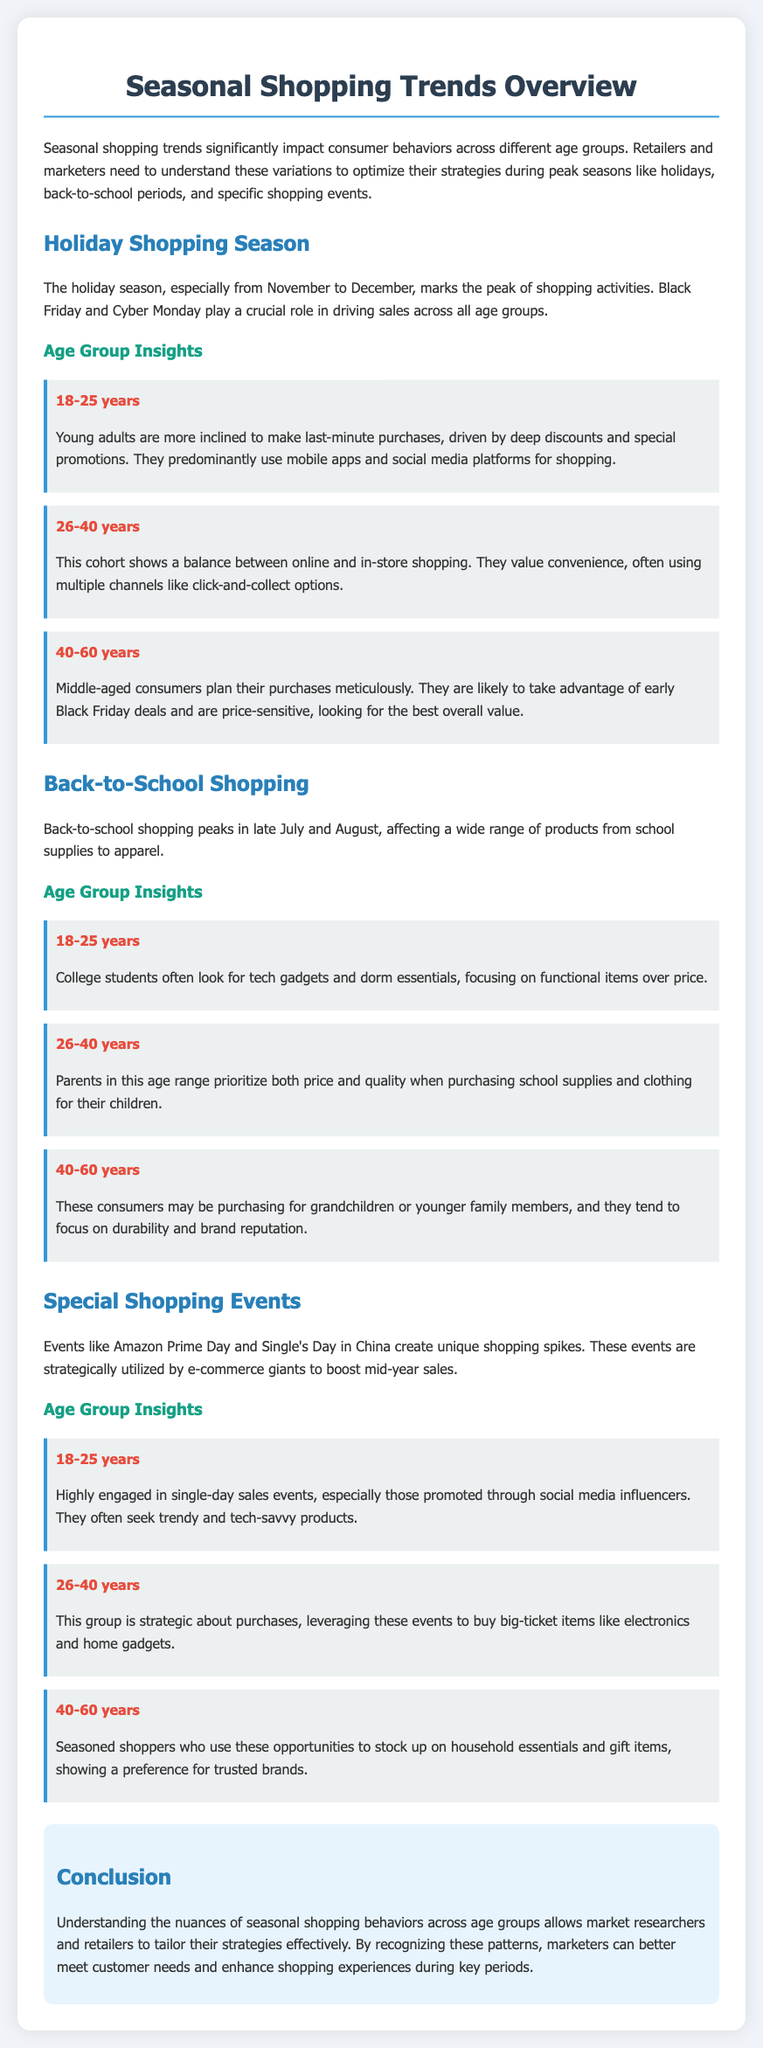What age group predominantly uses mobile apps for shopping during the holiday season? The young adults in the 18-25 years category predominantly use mobile apps and social media platforms for shopping during the holiday season.
Answer: 18-25 years Which shopping season peaks in late July and August? The back-to-school shopping season peaks in late July and August.
Answer: Back-to-school shopping What do 40-60-year-olds focus on when shopping during special events? The 40-60 years age group focuses on stocking up on household essentials and gift items, showing a preference for trusted brands during special shopping events.
Answer: Household essentials and gift items In which shopping event do young adults particularly engage with social media influencers? Young adults engage particularly with social media influencers during Single's Day.
Answer: Single's Day What do parents aged 26-40 prioritize when purchasing school supplies? Parents in the 26-40 age range prioritize both price and quality when purchasing school supplies.
Answer: Price and quality What retailers should understand to optimize their strategies during peak seasons? Retailers need to understand the variations in consumer behaviors across different age groups to optimize their strategies during peak seasons.
Answer: Variations in consumer behaviors What is the primary purchase motivation for middle-aged consumers during the holiday season? Middle-aged consumers are likely to take advantage of early Black Friday deals and are price-sensitive, looking for the best overall value.
Answer: Price-sensitive, best overall value What type of products do college students focus on for back-to-school shopping? College students focus on tech gadgets and dorm essentials for back-to-school shopping.
Answer: Tech gadgets and dorm essentials What is the conclusion drawn about understanding seasonal shopping behaviors? Understanding the nuances of seasonal shopping behaviors allows market researchers and retailers to tailor their strategies effectively.
Answer: Tailor strategies effectively 